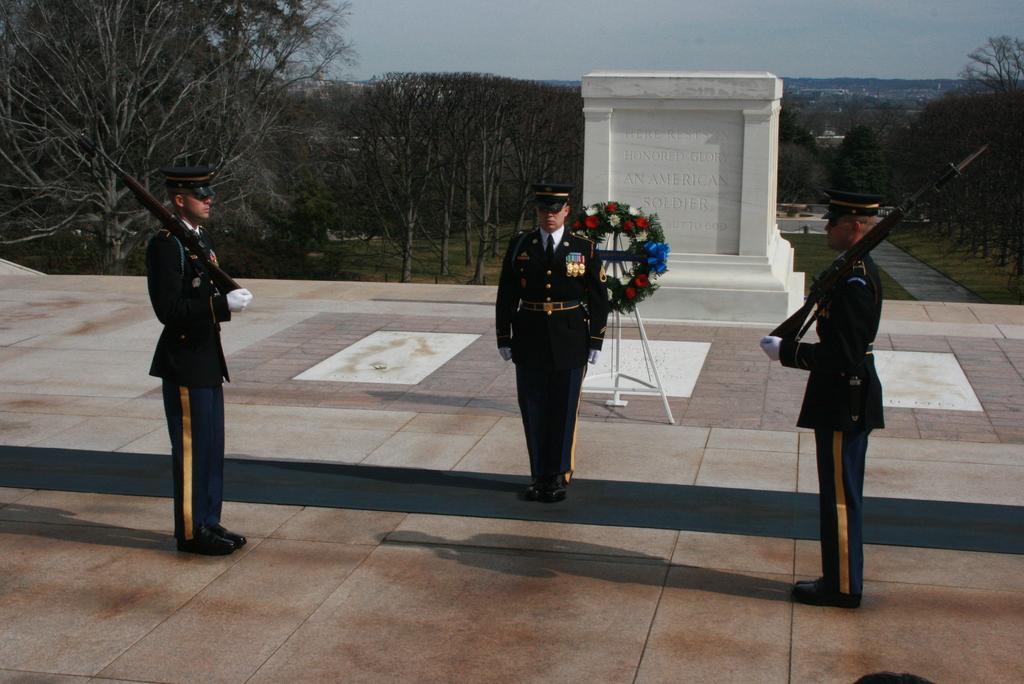Can you describe this image briefly? In this picture there are two persons standing and holding the gun and there is a person standing. At the back there is a garland on the stand and there is a wall. At the back there are trees. At the top there is sky. At the bottom there is grass. 